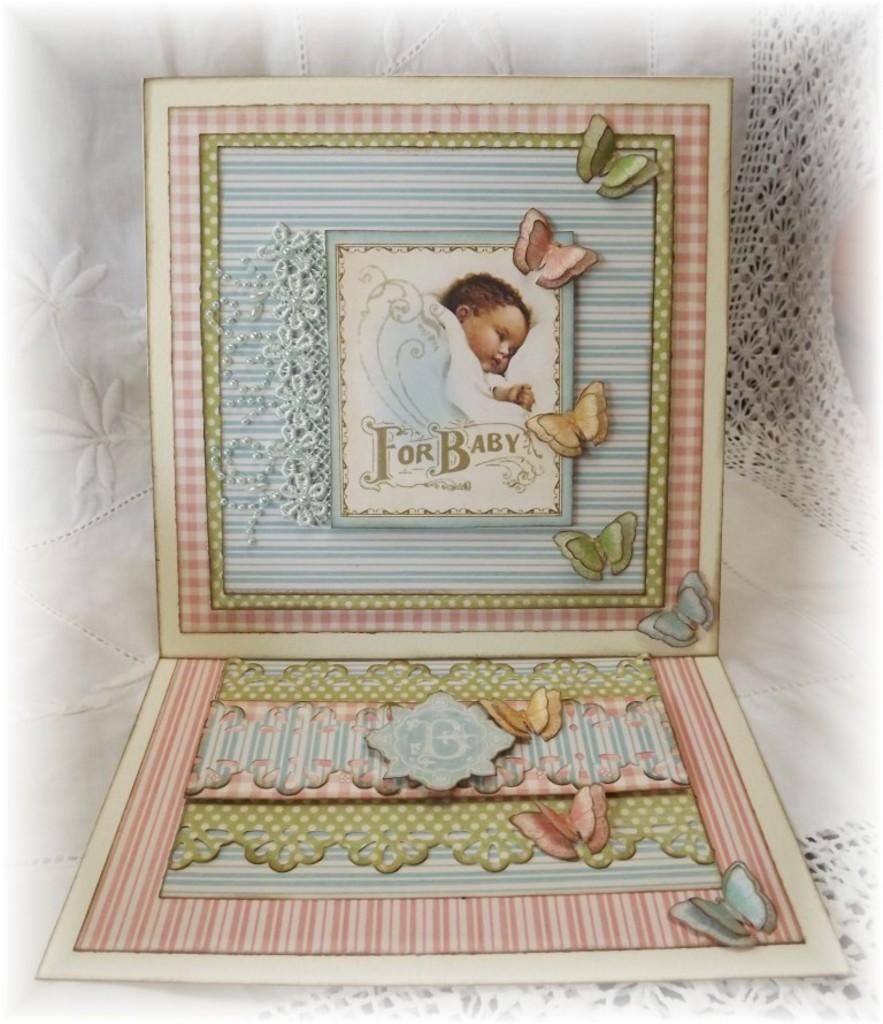<image>
Create a compact narrative representing the image presented. drawing of baby under a blanket with words 'for baby' on it surrounded by blue and pink patterns and butterflies 